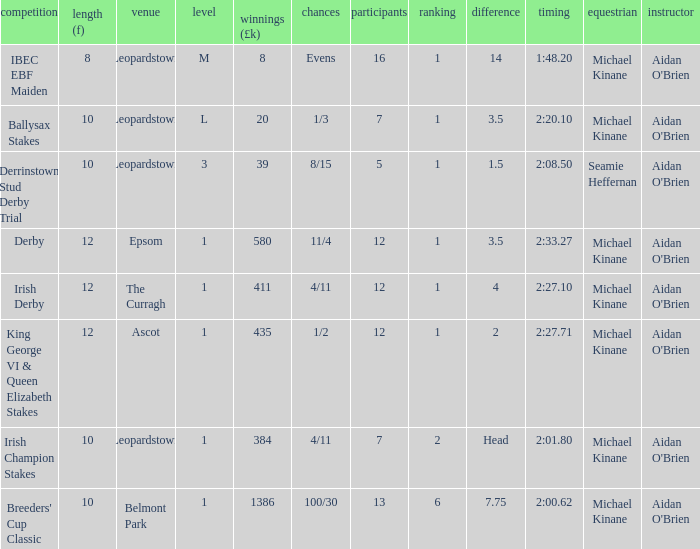Which Class has a Jockey of michael kinane on 2:27.71? 1.0. 